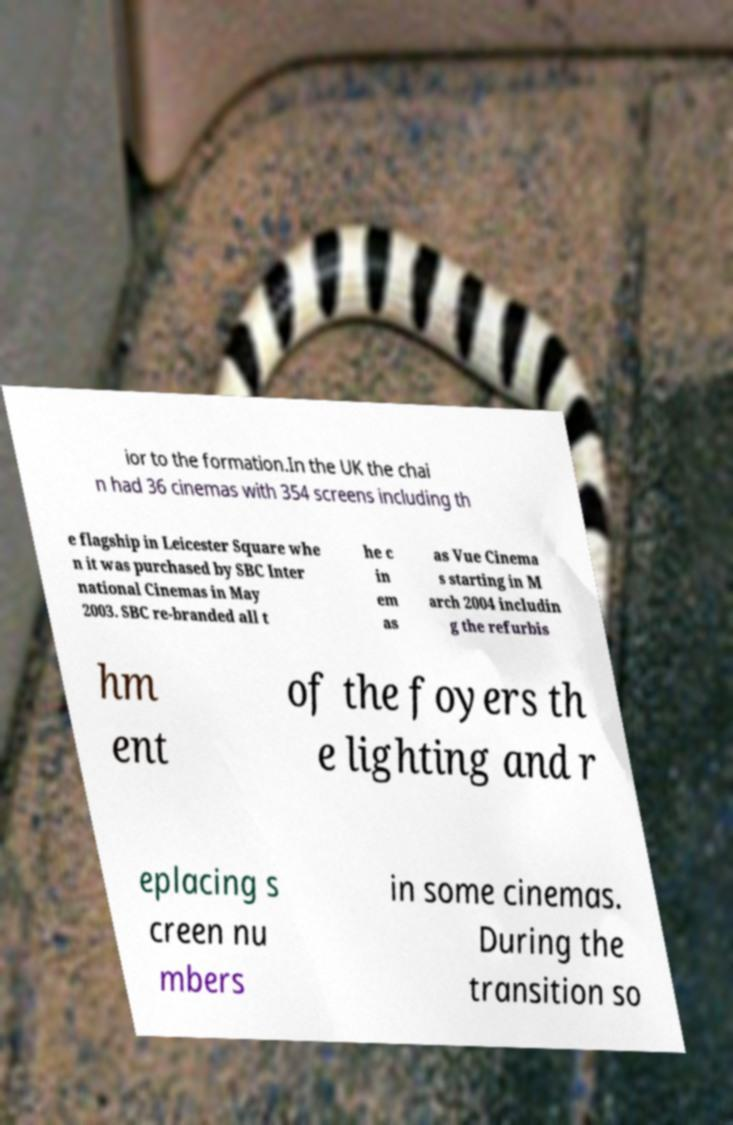Could you assist in decoding the text presented in this image and type it out clearly? ior to the formation.In the UK the chai n had 36 cinemas with 354 screens including th e flagship in Leicester Square whe n it was purchased by SBC Inter national Cinemas in May 2003. SBC re-branded all t he c in em as as Vue Cinema s starting in M arch 2004 includin g the refurbis hm ent of the foyers th e lighting and r eplacing s creen nu mbers in some cinemas. During the transition so 